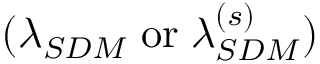Convert formula to latex. <formula><loc_0><loc_0><loc_500><loc_500>( \lambda _ { S D M } \, o r \, \lambda _ { S D M } ^ { ( s ) } )</formula> 